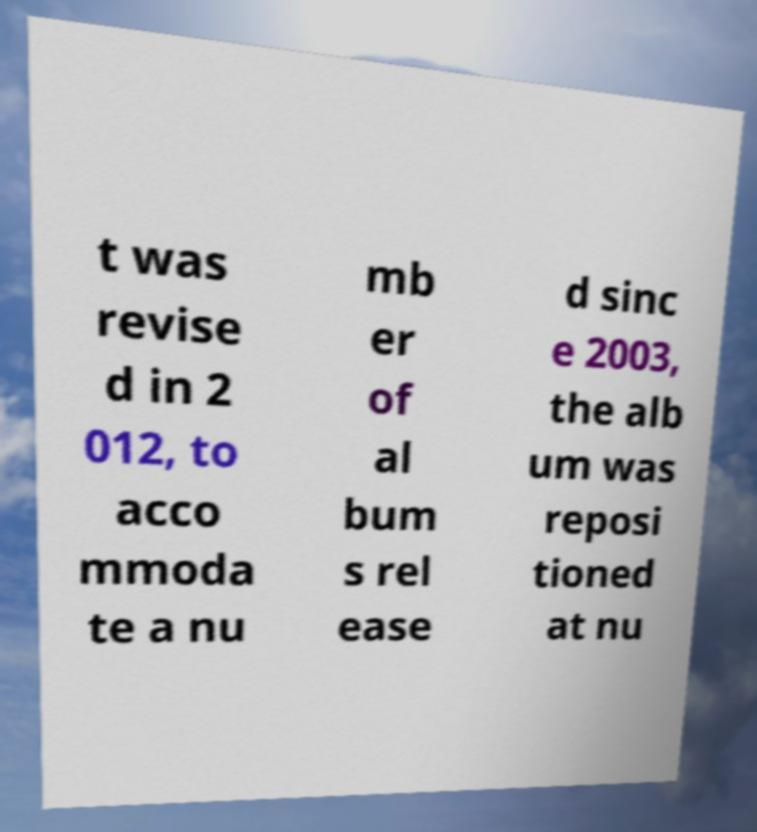Can you read and provide the text displayed in the image?This photo seems to have some interesting text. Can you extract and type it out for me? t was revise d in 2 012, to acco mmoda te a nu mb er of al bum s rel ease d sinc e 2003, the alb um was reposi tioned at nu 